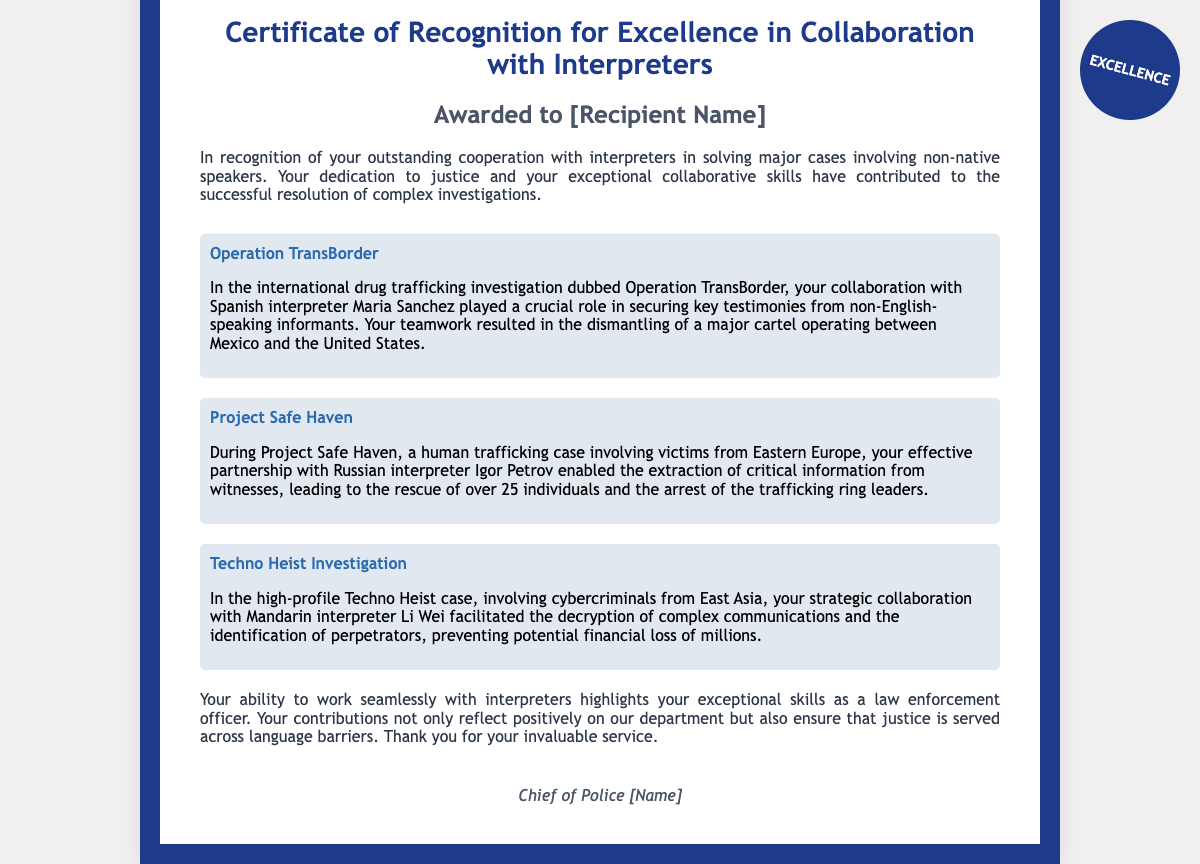what is the title of the document? The title of the document is presented at the top and is indicative of its purpose.
Answer: Certificate of Recognition for Excellence in Collaboration with Interpreters who is the recipient of the award? The document states a placeholder for the recipient's name, which would be specified in the final version.
Answer: [Recipient Name] what is the name of the first case study? The first case study is listed with a title that highlights its significance in the context.
Answer: Operation TransBorder who was the interpreter in Operation TransBorder? The document specifies the interpreter who was a key collaborator in this case study.
Answer: Maria Sanchez how many individuals were rescued in Project Safe Haven? The document provides a specific number related to the success of the operation mentioned.
Answer: over 25 individuals which language did the interpreter in Techno Heist Investigation speak? The document identifies the specific language associated with the interpreter mentioned.
Answer: Mandarin what was the outcome of the Techno Heist case? The document states the result of this investigation, emphasizing its importance.
Answer: preventing potential financial loss of millions what do the case studies illustrate about the recipient's skills? The document explains the type of contributions made by the recipient in collaboration with interpreters.
Answer: exceptional collaborative skills who signed the certificate? The document includes a signature area indicating the authority behind the award.
Answer: Chief of Police [Name] 